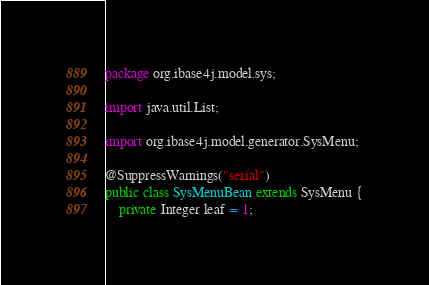<code> <loc_0><loc_0><loc_500><loc_500><_Java_>package org.ibase4j.model.sys;

import java.util.List;

import org.ibase4j.model.generator.SysMenu;

@SuppressWarnings("serial")
public class SysMenuBean extends SysMenu {
	private Integer leaf = 1;</code> 